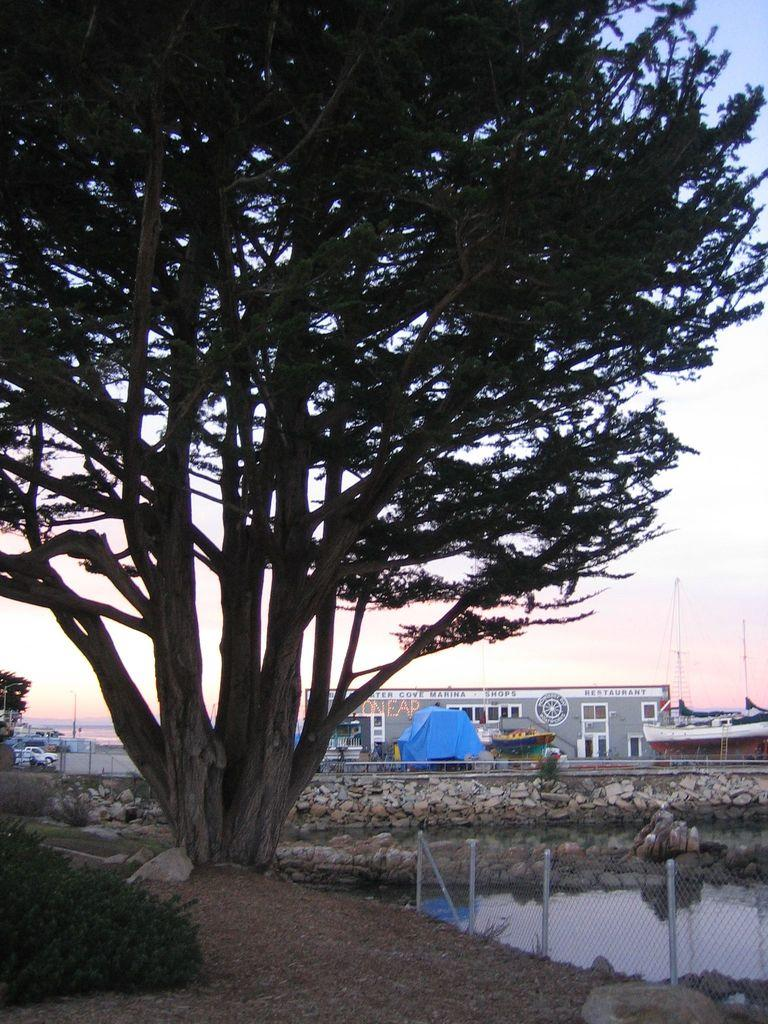What is the primary element visible in the image? There is water in the image. What type of structure can be seen in the image? There is a fence in the image. What type of vegetation is present in the image? There are plants and trees in the image. What type of transportation can be seen in the image? There are boats and a vehicle in the image. What type of building is visible in the image? There is a building in the image. What is visible in the background of the image? The sky is visible in the background of the image. How many birds are sitting on the comb in the image? There are no birds or combs present in the image. 